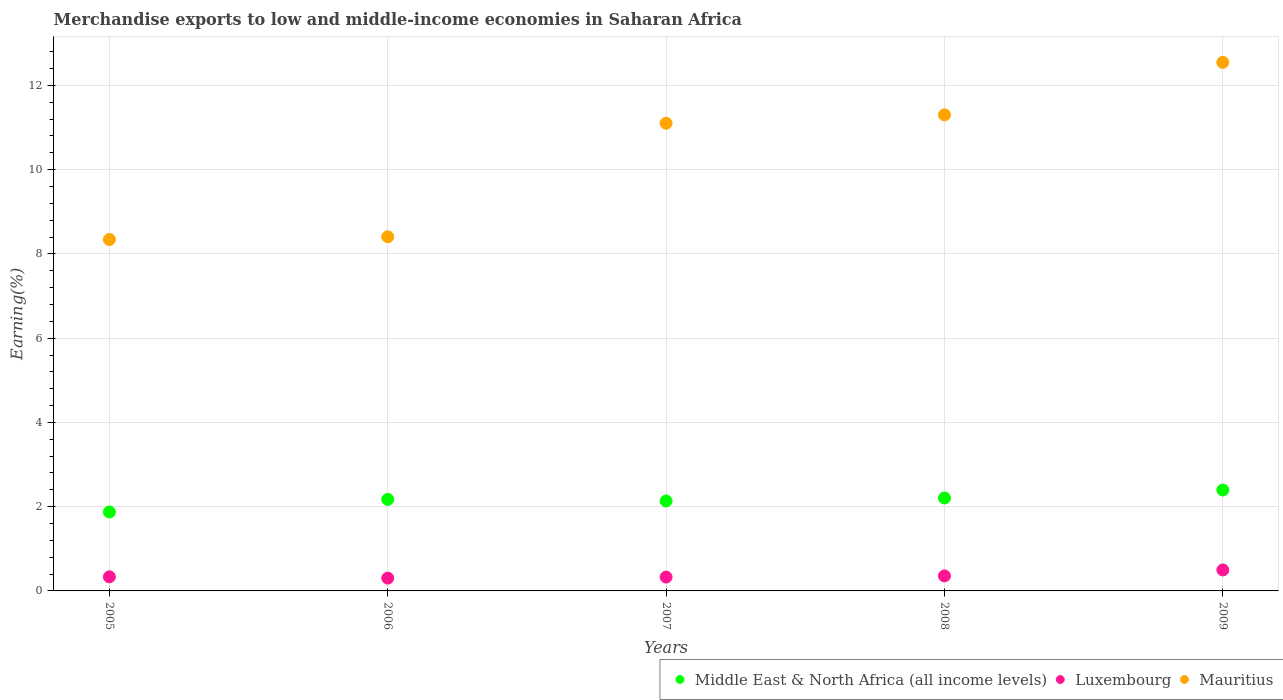How many different coloured dotlines are there?
Provide a succinct answer. 3. What is the percentage of amount earned from merchandise exports in Mauritius in 2005?
Offer a terse response. 8.34. Across all years, what is the maximum percentage of amount earned from merchandise exports in Luxembourg?
Give a very brief answer. 0.5. Across all years, what is the minimum percentage of amount earned from merchandise exports in Middle East & North Africa (all income levels)?
Keep it short and to the point. 1.87. In which year was the percentage of amount earned from merchandise exports in Mauritius minimum?
Your response must be concise. 2005. What is the total percentage of amount earned from merchandise exports in Luxembourg in the graph?
Offer a terse response. 1.82. What is the difference between the percentage of amount earned from merchandise exports in Middle East & North Africa (all income levels) in 2005 and that in 2007?
Offer a terse response. -0.26. What is the difference between the percentage of amount earned from merchandise exports in Middle East & North Africa (all income levels) in 2007 and the percentage of amount earned from merchandise exports in Luxembourg in 2009?
Give a very brief answer. 1.64. What is the average percentage of amount earned from merchandise exports in Luxembourg per year?
Your answer should be very brief. 0.36. In the year 2009, what is the difference between the percentage of amount earned from merchandise exports in Mauritius and percentage of amount earned from merchandise exports in Middle East & North Africa (all income levels)?
Make the answer very short. 10.15. In how many years, is the percentage of amount earned from merchandise exports in Luxembourg greater than 1.2000000000000002 %?
Give a very brief answer. 0. What is the ratio of the percentage of amount earned from merchandise exports in Mauritius in 2005 to that in 2009?
Your response must be concise. 0.66. Is the percentage of amount earned from merchandise exports in Luxembourg in 2005 less than that in 2009?
Your answer should be compact. Yes. What is the difference between the highest and the second highest percentage of amount earned from merchandise exports in Luxembourg?
Give a very brief answer. 0.14. What is the difference between the highest and the lowest percentage of amount earned from merchandise exports in Luxembourg?
Offer a terse response. 0.19. Is the sum of the percentage of amount earned from merchandise exports in Middle East & North Africa (all income levels) in 2005 and 2008 greater than the maximum percentage of amount earned from merchandise exports in Luxembourg across all years?
Your answer should be very brief. Yes. Does the percentage of amount earned from merchandise exports in Luxembourg monotonically increase over the years?
Keep it short and to the point. No. Are the values on the major ticks of Y-axis written in scientific E-notation?
Your response must be concise. No. How many legend labels are there?
Provide a short and direct response. 3. How are the legend labels stacked?
Offer a terse response. Horizontal. What is the title of the graph?
Your answer should be very brief. Merchandise exports to low and middle-income economies in Saharan Africa. What is the label or title of the Y-axis?
Provide a succinct answer. Earning(%). What is the Earning(%) of Middle East & North Africa (all income levels) in 2005?
Your answer should be very brief. 1.87. What is the Earning(%) in Luxembourg in 2005?
Make the answer very short. 0.33. What is the Earning(%) of Mauritius in 2005?
Your answer should be very brief. 8.34. What is the Earning(%) in Middle East & North Africa (all income levels) in 2006?
Make the answer very short. 2.17. What is the Earning(%) in Luxembourg in 2006?
Give a very brief answer. 0.3. What is the Earning(%) in Mauritius in 2006?
Provide a succinct answer. 8.41. What is the Earning(%) of Middle East & North Africa (all income levels) in 2007?
Offer a terse response. 2.13. What is the Earning(%) of Luxembourg in 2007?
Provide a succinct answer. 0.33. What is the Earning(%) of Mauritius in 2007?
Provide a short and direct response. 11.1. What is the Earning(%) of Middle East & North Africa (all income levels) in 2008?
Give a very brief answer. 2.21. What is the Earning(%) in Luxembourg in 2008?
Your answer should be very brief. 0.36. What is the Earning(%) in Mauritius in 2008?
Provide a succinct answer. 11.3. What is the Earning(%) of Middle East & North Africa (all income levels) in 2009?
Keep it short and to the point. 2.4. What is the Earning(%) of Luxembourg in 2009?
Offer a very short reply. 0.5. What is the Earning(%) in Mauritius in 2009?
Your answer should be very brief. 12.55. Across all years, what is the maximum Earning(%) of Middle East & North Africa (all income levels)?
Offer a very short reply. 2.4. Across all years, what is the maximum Earning(%) in Luxembourg?
Provide a short and direct response. 0.5. Across all years, what is the maximum Earning(%) of Mauritius?
Make the answer very short. 12.55. Across all years, what is the minimum Earning(%) of Middle East & North Africa (all income levels)?
Your answer should be compact. 1.87. Across all years, what is the minimum Earning(%) in Luxembourg?
Keep it short and to the point. 0.3. Across all years, what is the minimum Earning(%) in Mauritius?
Offer a terse response. 8.34. What is the total Earning(%) of Middle East & North Africa (all income levels) in the graph?
Offer a very short reply. 10.78. What is the total Earning(%) of Luxembourg in the graph?
Your answer should be compact. 1.82. What is the total Earning(%) in Mauritius in the graph?
Your answer should be very brief. 51.7. What is the difference between the Earning(%) of Middle East & North Africa (all income levels) in 2005 and that in 2006?
Offer a terse response. -0.3. What is the difference between the Earning(%) in Luxembourg in 2005 and that in 2006?
Provide a short and direct response. 0.03. What is the difference between the Earning(%) in Mauritius in 2005 and that in 2006?
Your answer should be very brief. -0.07. What is the difference between the Earning(%) of Middle East & North Africa (all income levels) in 2005 and that in 2007?
Ensure brevity in your answer.  -0.26. What is the difference between the Earning(%) in Luxembourg in 2005 and that in 2007?
Your answer should be very brief. 0.01. What is the difference between the Earning(%) of Mauritius in 2005 and that in 2007?
Give a very brief answer. -2.76. What is the difference between the Earning(%) in Middle East & North Africa (all income levels) in 2005 and that in 2008?
Ensure brevity in your answer.  -0.33. What is the difference between the Earning(%) of Luxembourg in 2005 and that in 2008?
Offer a terse response. -0.02. What is the difference between the Earning(%) of Mauritius in 2005 and that in 2008?
Offer a very short reply. -2.96. What is the difference between the Earning(%) in Middle East & North Africa (all income levels) in 2005 and that in 2009?
Your response must be concise. -0.52. What is the difference between the Earning(%) of Luxembourg in 2005 and that in 2009?
Provide a succinct answer. -0.16. What is the difference between the Earning(%) of Mauritius in 2005 and that in 2009?
Offer a terse response. -4.21. What is the difference between the Earning(%) in Middle East & North Africa (all income levels) in 2006 and that in 2007?
Keep it short and to the point. 0.04. What is the difference between the Earning(%) of Luxembourg in 2006 and that in 2007?
Offer a very short reply. -0.02. What is the difference between the Earning(%) of Mauritius in 2006 and that in 2007?
Keep it short and to the point. -2.7. What is the difference between the Earning(%) in Middle East & North Africa (all income levels) in 2006 and that in 2008?
Give a very brief answer. -0.03. What is the difference between the Earning(%) in Luxembourg in 2006 and that in 2008?
Ensure brevity in your answer.  -0.05. What is the difference between the Earning(%) in Mauritius in 2006 and that in 2008?
Your answer should be very brief. -2.89. What is the difference between the Earning(%) in Middle East & North Africa (all income levels) in 2006 and that in 2009?
Offer a very short reply. -0.22. What is the difference between the Earning(%) in Luxembourg in 2006 and that in 2009?
Make the answer very short. -0.19. What is the difference between the Earning(%) of Mauritius in 2006 and that in 2009?
Your answer should be very brief. -4.14. What is the difference between the Earning(%) of Middle East & North Africa (all income levels) in 2007 and that in 2008?
Keep it short and to the point. -0.07. What is the difference between the Earning(%) of Luxembourg in 2007 and that in 2008?
Offer a terse response. -0.03. What is the difference between the Earning(%) in Mauritius in 2007 and that in 2008?
Your answer should be compact. -0.2. What is the difference between the Earning(%) in Middle East & North Africa (all income levels) in 2007 and that in 2009?
Ensure brevity in your answer.  -0.26. What is the difference between the Earning(%) in Luxembourg in 2007 and that in 2009?
Offer a very short reply. -0.17. What is the difference between the Earning(%) in Mauritius in 2007 and that in 2009?
Provide a short and direct response. -1.45. What is the difference between the Earning(%) of Middle East & North Africa (all income levels) in 2008 and that in 2009?
Your answer should be very brief. -0.19. What is the difference between the Earning(%) of Luxembourg in 2008 and that in 2009?
Offer a very short reply. -0.14. What is the difference between the Earning(%) of Mauritius in 2008 and that in 2009?
Keep it short and to the point. -1.25. What is the difference between the Earning(%) of Middle East & North Africa (all income levels) in 2005 and the Earning(%) of Luxembourg in 2006?
Your answer should be very brief. 1.57. What is the difference between the Earning(%) of Middle East & North Africa (all income levels) in 2005 and the Earning(%) of Mauritius in 2006?
Your answer should be compact. -6.53. What is the difference between the Earning(%) in Luxembourg in 2005 and the Earning(%) in Mauritius in 2006?
Your response must be concise. -8.07. What is the difference between the Earning(%) in Middle East & North Africa (all income levels) in 2005 and the Earning(%) in Luxembourg in 2007?
Provide a short and direct response. 1.54. What is the difference between the Earning(%) of Middle East & North Africa (all income levels) in 2005 and the Earning(%) of Mauritius in 2007?
Offer a very short reply. -9.23. What is the difference between the Earning(%) in Luxembourg in 2005 and the Earning(%) in Mauritius in 2007?
Your answer should be compact. -10.77. What is the difference between the Earning(%) of Middle East & North Africa (all income levels) in 2005 and the Earning(%) of Luxembourg in 2008?
Provide a short and direct response. 1.52. What is the difference between the Earning(%) of Middle East & North Africa (all income levels) in 2005 and the Earning(%) of Mauritius in 2008?
Provide a short and direct response. -9.43. What is the difference between the Earning(%) of Luxembourg in 2005 and the Earning(%) of Mauritius in 2008?
Ensure brevity in your answer.  -10.97. What is the difference between the Earning(%) of Middle East & North Africa (all income levels) in 2005 and the Earning(%) of Luxembourg in 2009?
Give a very brief answer. 1.38. What is the difference between the Earning(%) in Middle East & North Africa (all income levels) in 2005 and the Earning(%) in Mauritius in 2009?
Your answer should be compact. -10.67. What is the difference between the Earning(%) of Luxembourg in 2005 and the Earning(%) of Mauritius in 2009?
Provide a succinct answer. -12.21. What is the difference between the Earning(%) in Middle East & North Africa (all income levels) in 2006 and the Earning(%) in Luxembourg in 2007?
Your response must be concise. 1.84. What is the difference between the Earning(%) of Middle East & North Africa (all income levels) in 2006 and the Earning(%) of Mauritius in 2007?
Keep it short and to the point. -8.93. What is the difference between the Earning(%) of Luxembourg in 2006 and the Earning(%) of Mauritius in 2007?
Give a very brief answer. -10.8. What is the difference between the Earning(%) of Middle East & North Africa (all income levels) in 2006 and the Earning(%) of Luxembourg in 2008?
Make the answer very short. 1.82. What is the difference between the Earning(%) of Middle East & North Africa (all income levels) in 2006 and the Earning(%) of Mauritius in 2008?
Your answer should be very brief. -9.13. What is the difference between the Earning(%) of Luxembourg in 2006 and the Earning(%) of Mauritius in 2008?
Your answer should be compact. -11. What is the difference between the Earning(%) of Middle East & North Africa (all income levels) in 2006 and the Earning(%) of Luxembourg in 2009?
Your answer should be very brief. 1.68. What is the difference between the Earning(%) of Middle East & North Africa (all income levels) in 2006 and the Earning(%) of Mauritius in 2009?
Your response must be concise. -10.37. What is the difference between the Earning(%) in Luxembourg in 2006 and the Earning(%) in Mauritius in 2009?
Offer a very short reply. -12.24. What is the difference between the Earning(%) in Middle East & North Africa (all income levels) in 2007 and the Earning(%) in Luxembourg in 2008?
Your answer should be very brief. 1.78. What is the difference between the Earning(%) of Middle East & North Africa (all income levels) in 2007 and the Earning(%) of Mauritius in 2008?
Give a very brief answer. -9.17. What is the difference between the Earning(%) in Luxembourg in 2007 and the Earning(%) in Mauritius in 2008?
Your answer should be very brief. -10.97. What is the difference between the Earning(%) in Middle East & North Africa (all income levels) in 2007 and the Earning(%) in Luxembourg in 2009?
Give a very brief answer. 1.64. What is the difference between the Earning(%) of Middle East & North Africa (all income levels) in 2007 and the Earning(%) of Mauritius in 2009?
Your response must be concise. -10.41. What is the difference between the Earning(%) of Luxembourg in 2007 and the Earning(%) of Mauritius in 2009?
Make the answer very short. -12.22. What is the difference between the Earning(%) in Middle East & North Africa (all income levels) in 2008 and the Earning(%) in Luxembourg in 2009?
Provide a succinct answer. 1.71. What is the difference between the Earning(%) in Middle East & North Africa (all income levels) in 2008 and the Earning(%) in Mauritius in 2009?
Give a very brief answer. -10.34. What is the difference between the Earning(%) of Luxembourg in 2008 and the Earning(%) of Mauritius in 2009?
Provide a short and direct response. -12.19. What is the average Earning(%) in Middle East & North Africa (all income levels) per year?
Provide a succinct answer. 2.16. What is the average Earning(%) of Luxembourg per year?
Provide a short and direct response. 0.36. What is the average Earning(%) of Mauritius per year?
Offer a terse response. 10.34. In the year 2005, what is the difference between the Earning(%) of Middle East & North Africa (all income levels) and Earning(%) of Luxembourg?
Provide a short and direct response. 1.54. In the year 2005, what is the difference between the Earning(%) of Middle East & North Africa (all income levels) and Earning(%) of Mauritius?
Your response must be concise. -6.47. In the year 2005, what is the difference between the Earning(%) in Luxembourg and Earning(%) in Mauritius?
Offer a terse response. -8.01. In the year 2006, what is the difference between the Earning(%) in Middle East & North Africa (all income levels) and Earning(%) in Luxembourg?
Provide a short and direct response. 1.87. In the year 2006, what is the difference between the Earning(%) of Middle East & North Africa (all income levels) and Earning(%) of Mauritius?
Ensure brevity in your answer.  -6.23. In the year 2006, what is the difference between the Earning(%) of Luxembourg and Earning(%) of Mauritius?
Your response must be concise. -8.1. In the year 2007, what is the difference between the Earning(%) in Middle East & North Africa (all income levels) and Earning(%) in Luxembourg?
Give a very brief answer. 1.81. In the year 2007, what is the difference between the Earning(%) of Middle East & North Africa (all income levels) and Earning(%) of Mauritius?
Your answer should be very brief. -8.97. In the year 2007, what is the difference between the Earning(%) in Luxembourg and Earning(%) in Mauritius?
Make the answer very short. -10.77. In the year 2008, what is the difference between the Earning(%) of Middle East & North Africa (all income levels) and Earning(%) of Luxembourg?
Make the answer very short. 1.85. In the year 2008, what is the difference between the Earning(%) in Middle East & North Africa (all income levels) and Earning(%) in Mauritius?
Provide a succinct answer. -9.1. In the year 2008, what is the difference between the Earning(%) in Luxembourg and Earning(%) in Mauritius?
Give a very brief answer. -10.94. In the year 2009, what is the difference between the Earning(%) of Middle East & North Africa (all income levels) and Earning(%) of Luxembourg?
Offer a terse response. 1.9. In the year 2009, what is the difference between the Earning(%) in Middle East & North Africa (all income levels) and Earning(%) in Mauritius?
Provide a succinct answer. -10.15. In the year 2009, what is the difference between the Earning(%) of Luxembourg and Earning(%) of Mauritius?
Make the answer very short. -12.05. What is the ratio of the Earning(%) in Middle East & North Africa (all income levels) in 2005 to that in 2006?
Give a very brief answer. 0.86. What is the ratio of the Earning(%) in Luxembourg in 2005 to that in 2006?
Give a very brief answer. 1.1. What is the ratio of the Earning(%) of Middle East & North Africa (all income levels) in 2005 to that in 2007?
Give a very brief answer. 0.88. What is the ratio of the Earning(%) in Luxembourg in 2005 to that in 2007?
Give a very brief answer. 1.02. What is the ratio of the Earning(%) of Mauritius in 2005 to that in 2007?
Give a very brief answer. 0.75. What is the ratio of the Earning(%) of Middle East & North Africa (all income levels) in 2005 to that in 2008?
Your answer should be very brief. 0.85. What is the ratio of the Earning(%) in Luxembourg in 2005 to that in 2008?
Keep it short and to the point. 0.94. What is the ratio of the Earning(%) of Mauritius in 2005 to that in 2008?
Provide a succinct answer. 0.74. What is the ratio of the Earning(%) of Middle East & North Africa (all income levels) in 2005 to that in 2009?
Your answer should be very brief. 0.78. What is the ratio of the Earning(%) of Luxembourg in 2005 to that in 2009?
Your response must be concise. 0.67. What is the ratio of the Earning(%) of Mauritius in 2005 to that in 2009?
Your answer should be very brief. 0.66. What is the ratio of the Earning(%) in Middle East & North Africa (all income levels) in 2006 to that in 2007?
Offer a terse response. 1.02. What is the ratio of the Earning(%) of Luxembourg in 2006 to that in 2007?
Offer a very short reply. 0.92. What is the ratio of the Earning(%) of Mauritius in 2006 to that in 2007?
Your response must be concise. 0.76. What is the ratio of the Earning(%) of Middle East & North Africa (all income levels) in 2006 to that in 2008?
Keep it short and to the point. 0.98. What is the ratio of the Earning(%) of Luxembourg in 2006 to that in 2008?
Your response must be concise. 0.85. What is the ratio of the Earning(%) of Mauritius in 2006 to that in 2008?
Your response must be concise. 0.74. What is the ratio of the Earning(%) of Middle East & North Africa (all income levels) in 2006 to that in 2009?
Keep it short and to the point. 0.91. What is the ratio of the Earning(%) in Luxembourg in 2006 to that in 2009?
Offer a terse response. 0.61. What is the ratio of the Earning(%) of Mauritius in 2006 to that in 2009?
Provide a short and direct response. 0.67. What is the ratio of the Earning(%) of Middle East & North Africa (all income levels) in 2007 to that in 2008?
Your response must be concise. 0.97. What is the ratio of the Earning(%) of Luxembourg in 2007 to that in 2008?
Make the answer very short. 0.92. What is the ratio of the Earning(%) in Mauritius in 2007 to that in 2008?
Keep it short and to the point. 0.98. What is the ratio of the Earning(%) of Middle East & North Africa (all income levels) in 2007 to that in 2009?
Keep it short and to the point. 0.89. What is the ratio of the Earning(%) in Luxembourg in 2007 to that in 2009?
Your response must be concise. 0.66. What is the ratio of the Earning(%) of Mauritius in 2007 to that in 2009?
Offer a very short reply. 0.88. What is the ratio of the Earning(%) of Middle East & North Africa (all income levels) in 2008 to that in 2009?
Offer a very short reply. 0.92. What is the ratio of the Earning(%) of Luxembourg in 2008 to that in 2009?
Your answer should be very brief. 0.72. What is the ratio of the Earning(%) of Mauritius in 2008 to that in 2009?
Your answer should be compact. 0.9. What is the difference between the highest and the second highest Earning(%) in Middle East & North Africa (all income levels)?
Offer a very short reply. 0.19. What is the difference between the highest and the second highest Earning(%) in Luxembourg?
Your response must be concise. 0.14. What is the difference between the highest and the second highest Earning(%) of Mauritius?
Your answer should be compact. 1.25. What is the difference between the highest and the lowest Earning(%) in Middle East & North Africa (all income levels)?
Provide a short and direct response. 0.52. What is the difference between the highest and the lowest Earning(%) in Luxembourg?
Ensure brevity in your answer.  0.19. What is the difference between the highest and the lowest Earning(%) in Mauritius?
Offer a very short reply. 4.21. 